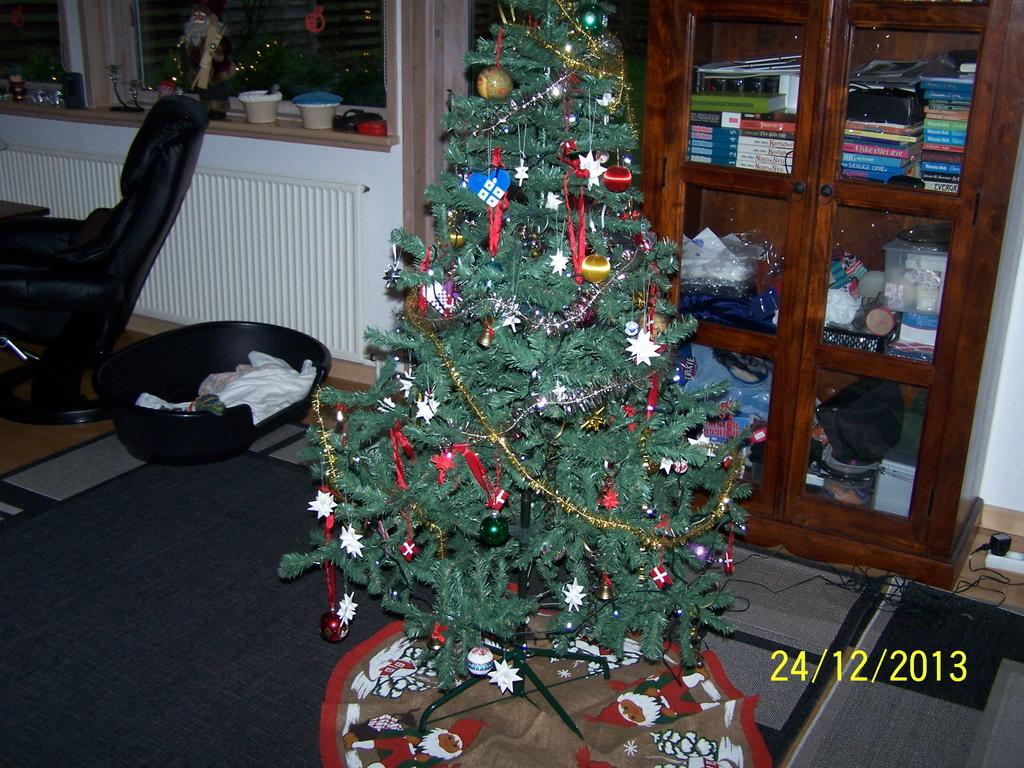What type of tree is in the image? There is a Christmas tree in the image. What type of furniture is in the image? There is a wooden table in the image. What is on top of the wooden table? The wooden table has books on it. What type of stitch is used to decorate the Christmas tree in the image? There is no stitching or decoration mentioned on the Christmas tree in the image. 